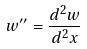Convert formula to latex. <formula><loc_0><loc_0><loc_500><loc_500>w ^ { \prime \prime } = \frac { d ^ { 2 } w } { d ^ { 2 } x }</formula> 